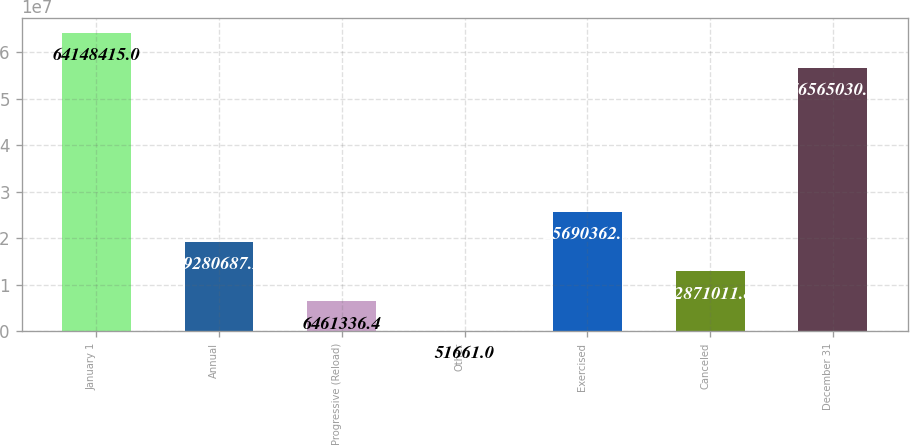<chart> <loc_0><loc_0><loc_500><loc_500><bar_chart><fcel>January 1<fcel>Annual<fcel>Progressive (Reload)<fcel>Other<fcel>Exercised<fcel>Canceled<fcel>December 31<nl><fcel>6.41484e+07<fcel>1.92807e+07<fcel>6.46134e+06<fcel>51661<fcel>2.56904e+07<fcel>1.2871e+07<fcel>5.6565e+07<nl></chart> 